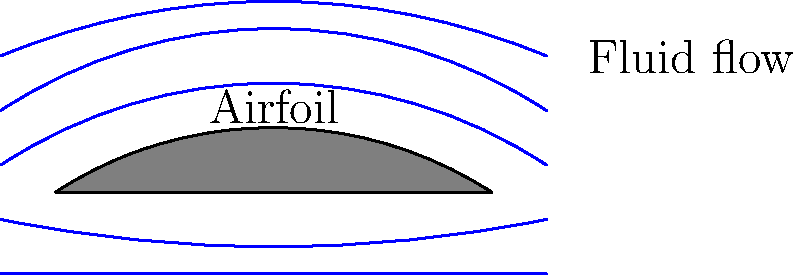In the context of deregulating the aerospace industry, how does the principle of streamline curvature around an airfoil, as shown in the diagram, impact the distribution of pressure and consequently affect lift generation? How might this understanding influence policy decisions regarding aircraft design regulations? To answer this question, we need to consider the following steps:

1. Streamline curvature principle: The curvature of streamlines around an airfoil is directly related to the pressure distribution.

2. Bernoulli's principle: As fluid velocity increases, pressure decreases, and vice versa.

3. Streamline behavior: 
   - Above the airfoil: Streamlines are more tightly curved and closer together, indicating higher velocity and lower pressure.
   - Below the airfoil: Streamlines are less curved and farther apart, indicating lower velocity and higher pressure.

4. Pressure difference: The pressure difference between the upper and lower surfaces of the airfoil generates lift.

5. Lift generation: The net upward force (lift) is a result of this pressure difference.

6. Policy implications:
   - Understanding this principle is crucial for setting safety standards in aircraft design.
   - Deregulation might allow for more innovative airfoil designs, potentially improving efficiency.
   - However, regulations must still ensure that new designs meet minimum lift and safety requirements.

7. Balancing act: Policymakers must weigh the benefits of design freedom against the need for standardized safety measures.

8. Economic considerations: More efficient designs could lead to fuel savings and economic benefits, which might influence deregulation decisions.

9. Testing and certification: New policies may need to address how novel airfoil designs are tested and certified for use.
Answer: Streamline curvature indicates pressure distribution, generating lift. Deregulation policies must balance innovation with safety standards in aircraft design. 